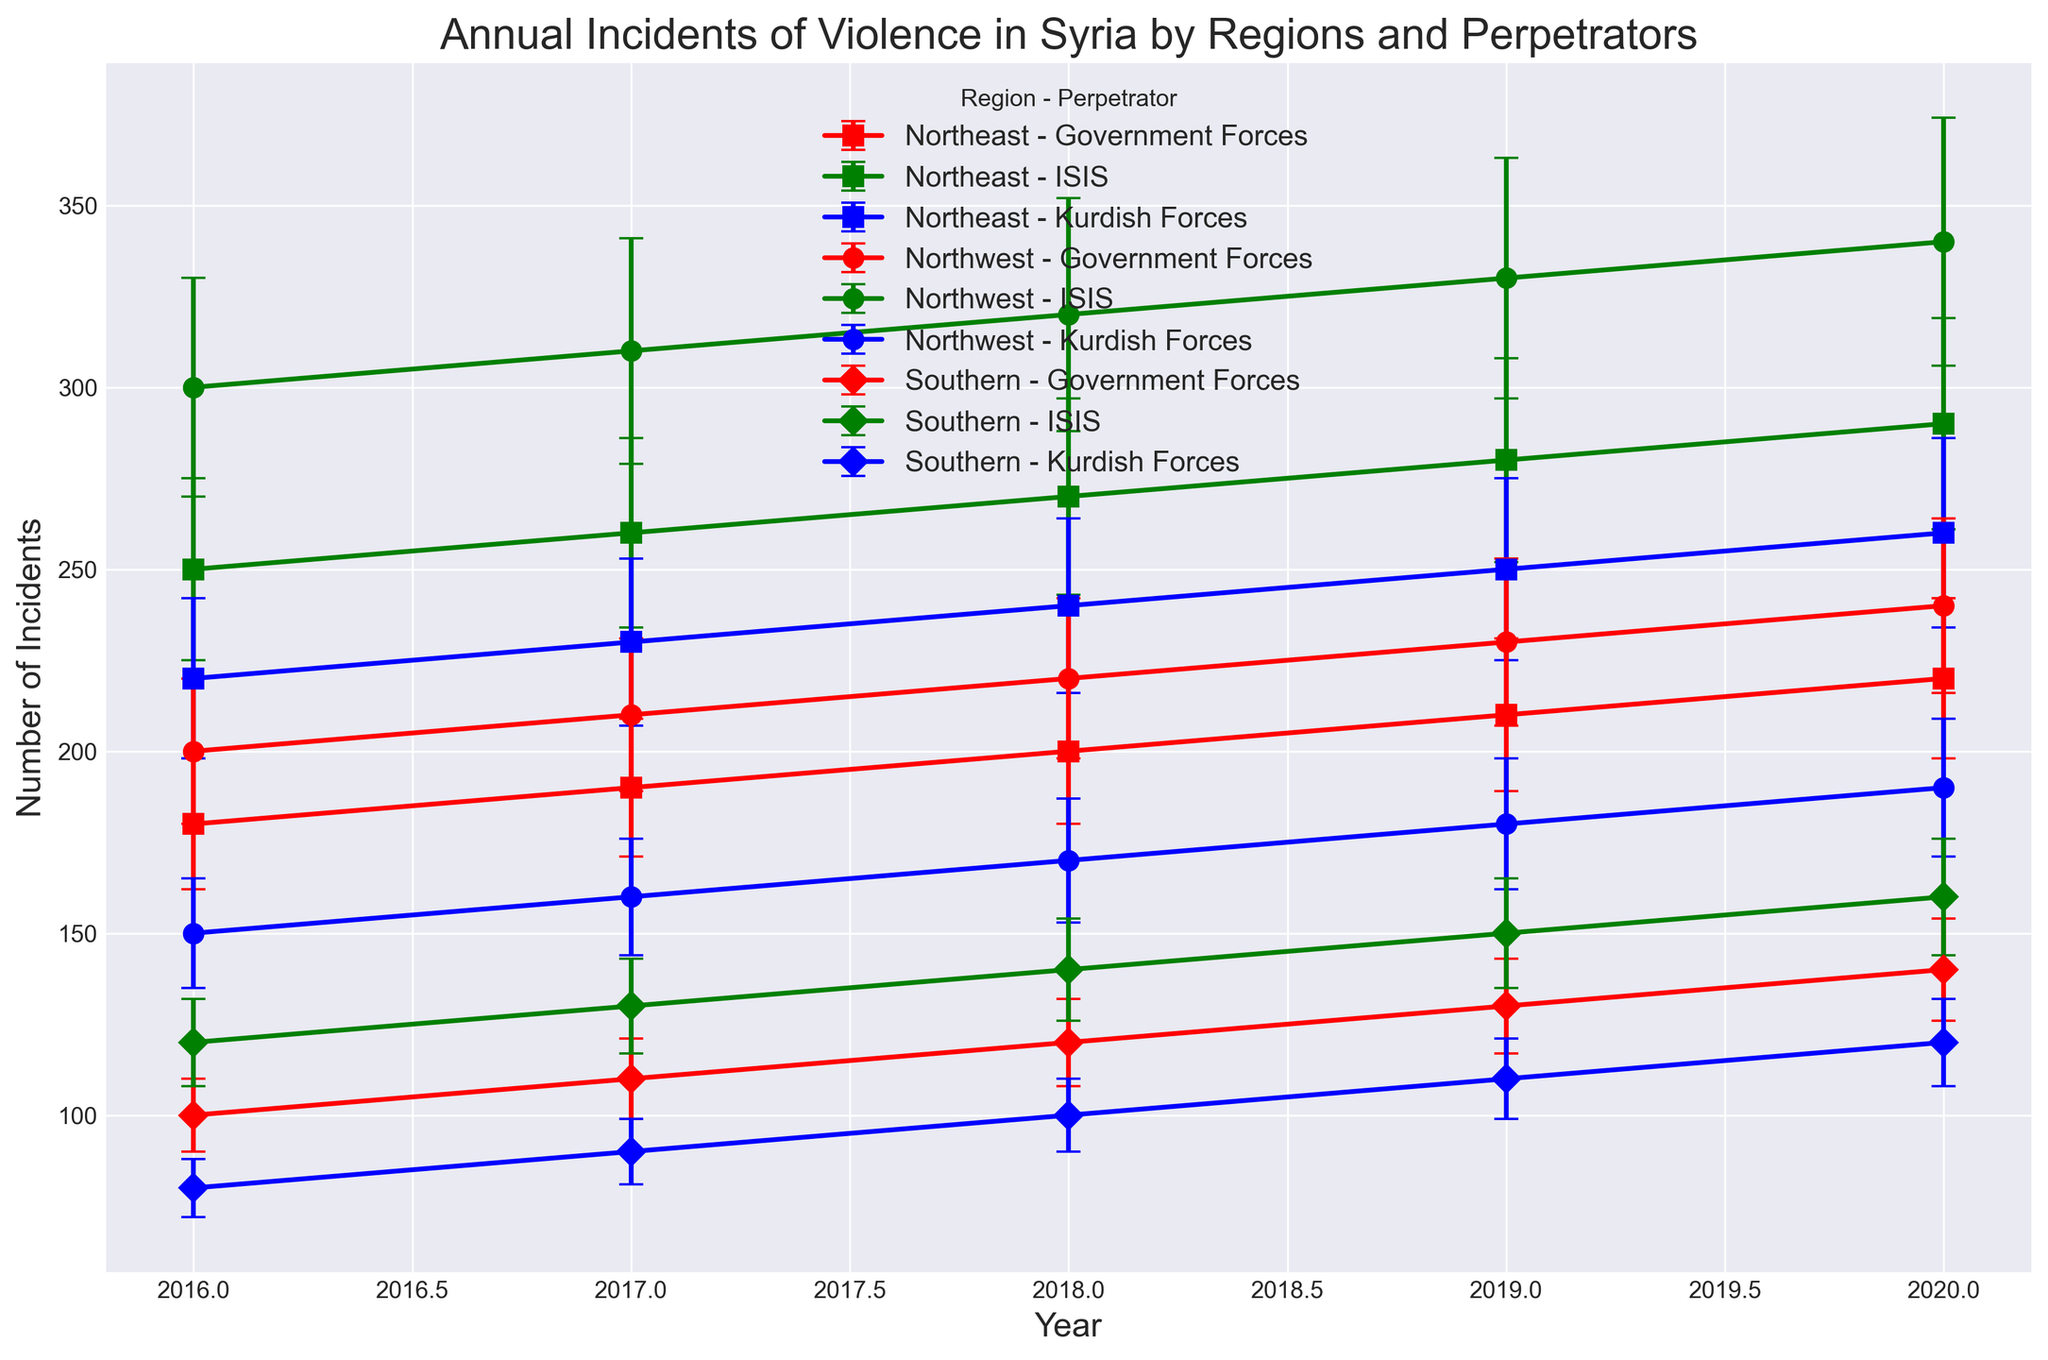Which region had the highest number of incidents caused by Government Forces in 2020? To find the region with the highest number of incidents caused by Government Forces, look at the data for 2020 and compare the incidents for each region. In 2020, the regions are Northwest, Northeast, and Southern, with incidents counts of 240, 220, and 140 respectively for Government Forces.
Answer: Northwest How many more incidents were there involving ISIS in the Northeast region compared to the Southern region in 2019? Look at the data for incidents involving ISIS in 2019 in both the Northeast and Southern regions. Subtract the number of incidents in the Southern region (150) from the number in the Northeast region (280). Calculation: 280 - 150 = 130
Answer: 130 What's the yearly trend of incidents involving Kurdish Forces in the Northwest region from 2016 to 2020? Analyze the plot data points for the incidents involving Kurdish Forces in the Northwest region from 2016 to 2020. The values are 150, 160, 170, 180, and 190 respectively, showing a consistent yearly increase.
Answer: Increasing What is the average number of incidents caused by Government Forces across all regions in 2018? First, identify the number of incidents caused by Government Forces in each region (Northwest: 220, Northeast: 200, Southern: 120). Sum these values and then divide by the number of regions (3). Calculation: (220 + 200 + 120) / 3 = 540 / 3 = 180
Answer: 180 Which perpetrator had the most significant increase in incidents in the Northwest region from 2019 to 2020? Compare the number of incidents for each perpetrator in 2019 and 2020 in the Northwest region. For Government Forces: 230 to 240, for Kurdish Forces: 180 to 190, and for ISIS: 330 to 340. The most significant increase is in the number of ISIS incidents (increase by 10).
Answer: ISIS Between 2016 and 2020, which year saw the highest total incidents of violence in the Northeast region across all perpetrators? Sum the incidents of violence for each year (2016 to 2020) in the Northeast region across all perpetrators. The total incidents are: 2016: 180 + 220 + 250 = 650, 2017: 190 + 230 + 260 = 680, 2018: 200 + 240 + 270 = 710, 2019: 210 + 250 + 280 = 740, 2020: 220 + 260 + 290 = 770. The year with the highest total is 2020.
Answer: 2020 